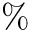<formula> <loc_0><loc_0><loc_500><loc_500>\%</formula> 